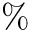<formula> <loc_0><loc_0><loc_500><loc_500>\%</formula> 